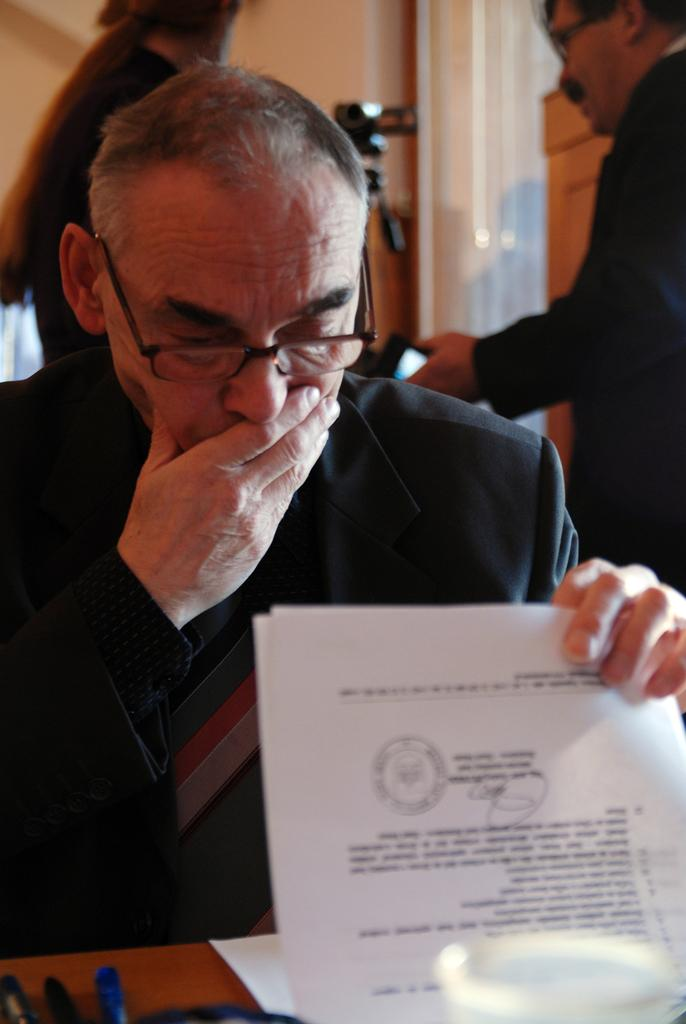What is the person in the image doing? The person is sitting in the image. What is the person wearing? The person is wearing a black color blazer. What is the person holding? The person is holding papers. What can be seen in the background of the image? There are other people standing in the background of the image, and the wall is cream-colored. What type of snail can be seen crawling on the person's blazer in the image? There is no snail present on the person's blazer in the image. What substance is the person using to write on the papers? The image does not provide information about the substance being used to write on the papers. 